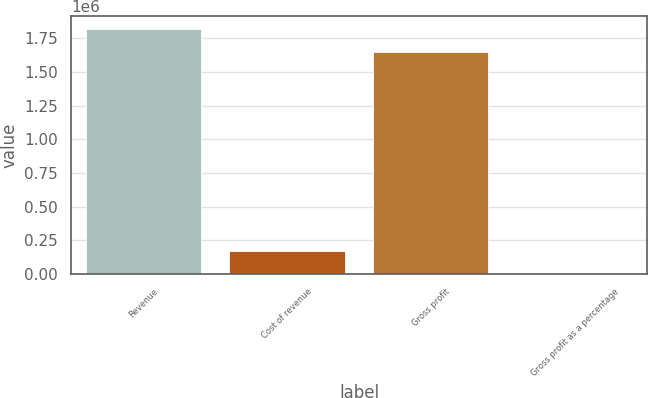Convert chart. <chart><loc_0><loc_0><loc_500><loc_500><bar_chart><fcel>Revenue<fcel>Cost of revenue<fcel>Gross profit<fcel>Gross profit as a percentage<nl><fcel>1.82113e+06<fcel>171406<fcel>1.64982e+06<fcel>96<nl></chart> 